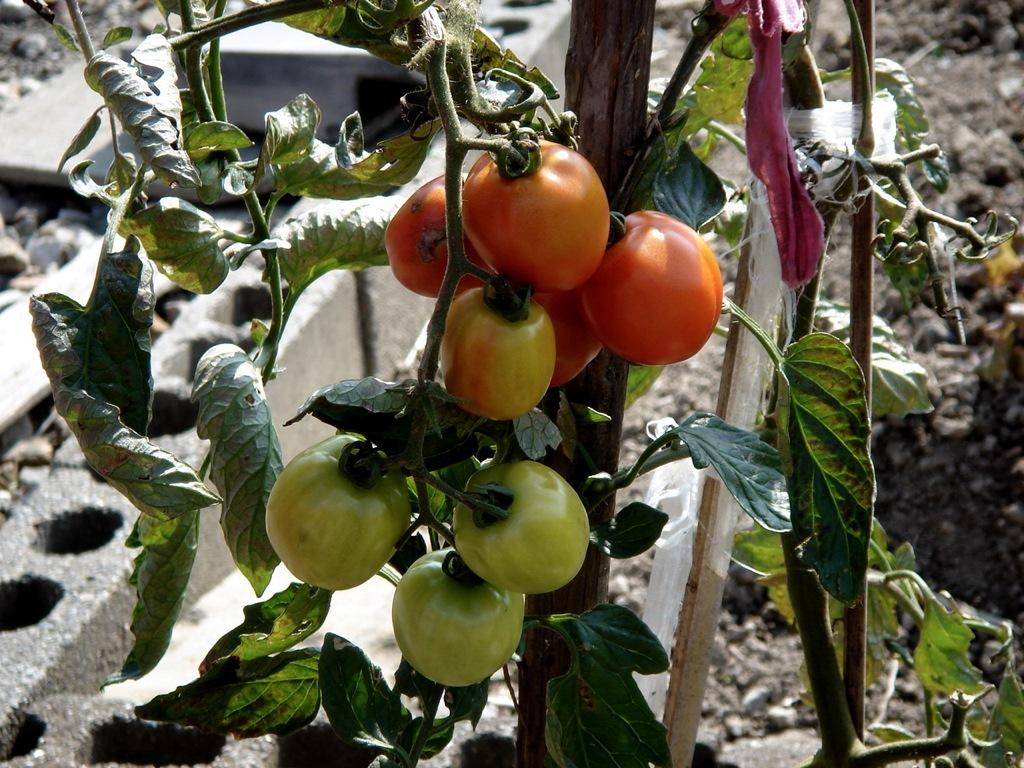What is located in the center of the image? There are tomatoes, a plant, sticks, and a cloth in the center of the image. Can you describe the plant in the center of the image? The plant in the center of the image is surrounded by tomatoes, sticks, and a cloth. What materials are present in the center of the image? The materials present in the center of the image include tomatoes, a plant, sticks, and a cloth. What can be seen in the background of the image? In the background of the image, there are rocks and mud. What type of drink is being poured from the tomatoes in the image? There is no drink being poured from the tomatoes in the image; they are simply present in the center of the image. Is there any paint visible on the plant in the image? There is no paint visible on the plant in the image; it is surrounded by tomatoes, sticks, and a cloth. 